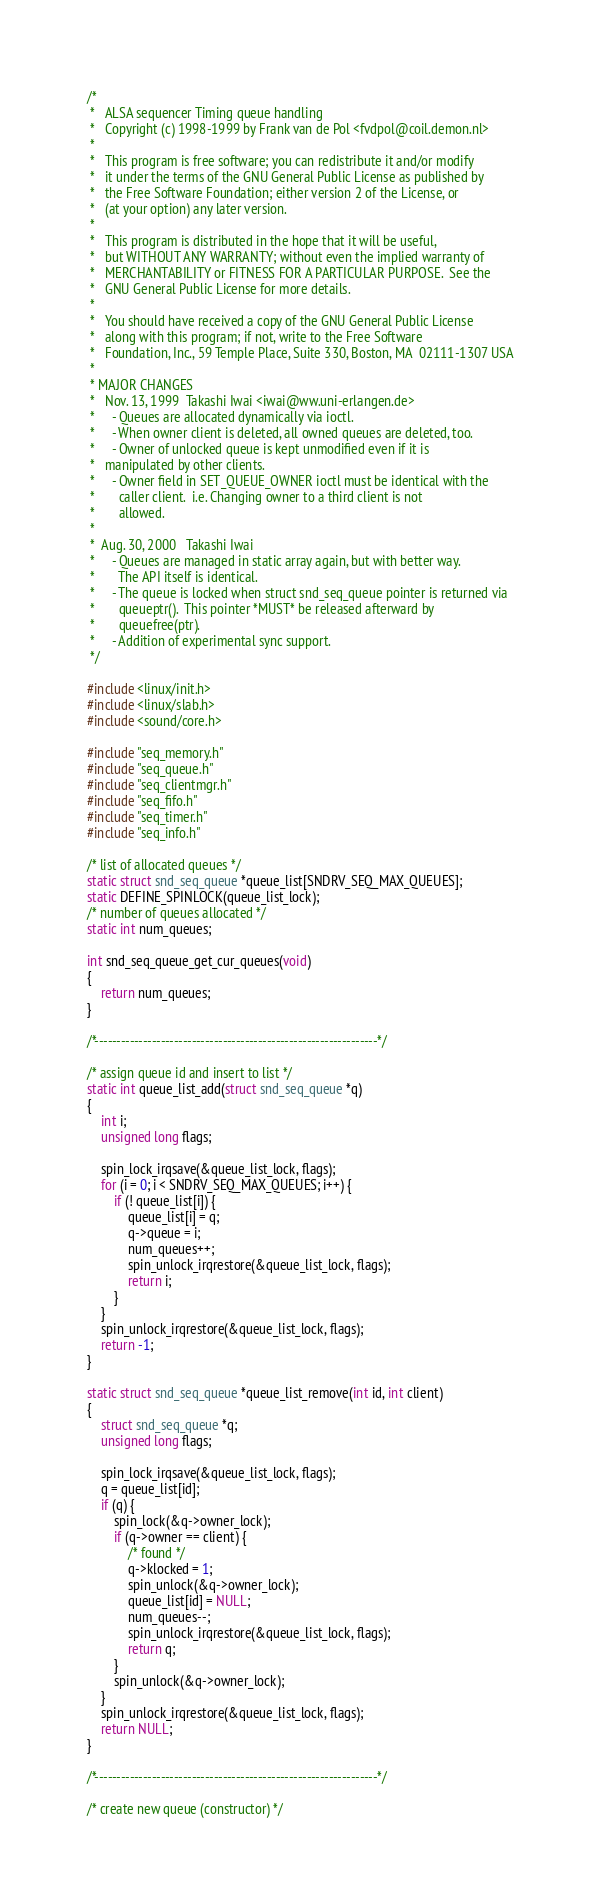Convert code to text. <code><loc_0><loc_0><loc_500><loc_500><_C_>/*
 *   ALSA sequencer Timing queue handling
 *   Copyright (c) 1998-1999 by Frank van de Pol <fvdpol@coil.demon.nl>
 *
 *   This program is free software; you can redistribute it and/or modify
 *   it under the terms of the GNU General Public License as published by
 *   the Free Software Foundation; either version 2 of the License, or
 *   (at your option) any later version.
 *
 *   This program is distributed in the hope that it will be useful,
 *   but WITHOUT ANY WARRANTY; without even the implied warranty of
 *   MERCHANTABILITY or FITNESS FOR A PARTICULAR PURPOSE.  See the
 *   GNU General Public License for more details.
 *
 *   You should have received a copy of the GNU General Public License
 *   along with this program; if not, write to the Free Software
 *   Foundation, Inc., 59 Temple Place, Suite 330, Boston, MA  02111-1307 USA
 *
 * MAJOR CHANGES
 *   Nov. 13, 1999	Takashi Iwai <iwai@ww.uni-erlangen.de>
 *     - Queues are allocated dynamically via ioctl.
 *     - When owner client is deleted, all owned queues are deleted, too.
 *     - Owner of unlocked queue is kept unmodified even if it is
 *	 manipulated by other clients.
 *     - Owner field in SET_QUEUE_OWNER ioctl must be identical with the
 *       caller client.  i.e. Changing owner to a third client is not
 *       allowed.
 *
 *  Aug. 30, 2000	Takashi Iwai
 *     - Queues are managed in static array again, but with better way.
 *       The API itself is identical.
 *     - The queue is locked when struct snd_seq_queue pointer is returned via
 *       queueptr().  This pointer *MUST* be released afterward by
 *       queuefree(ptr).
 *     - Addition of experimental sync support.
 */

#include <linux/init.h>
#include <linux/slab.h>
#include <sound/core.h>

#include "seq_memory.h"
#include "seq_queue.h"
#include "seq_clientmgr.h"
#include "seq_fifo.h"
#include "seq_timer.h"
#include "seq_info.h"

/* list of allocated queues */
static struct snd_seq_queue *queue_list[SNDRV_SEQ_MAX_QUEUES];
static DEFINE_SPINLOCK(queue_list_lock);
/* number of queues allocated */
static int num_queues;

int snd_seq_queue_get_cur_queues(void)
{
	return num_queues;
}

/*----------------------------------------------------------------*/

/* assign queue id and insert to list */
static int queue_list_add(struct snd_seq_queue *q)
{
	int i;
	unsigned long flags;

	spin_lock_irqsave(&queue_list_lock, flags);
	for (i = 0; i < SNDRV_SEQ_MAX_QUEUES; i++) {
		if (! queue_list[i]) {
			queue_list[i] = q;
			q->queue = i;
			num_queues++;
			spin_unlock_irqrestore(&queue_list_lock, flags);
			return i;
		}
	}
	spin_unlock_irqrestore(&queue_list_lock, flags);
	return -1;
}

static struct snd_seq_queue *queue_list_remove(int id, int client)
{
	struct snd_seq_queue *q;
	unsigned long flags;

	spin_lock_irqsave(&queue_list_lock, flags);
	q = queue_list[id];
	if (q) {
		spin_lock(&q->owner_lock);
		if (q->owner == client) {
			/* found */
			q->klocked = 1;
			spin_unlock(&q->owner_lock);
			queue_list[id] = NULL;
			num_queues--;
			spin_unlock_irqrestore(&queue_list_lock, flags);
			return q;
		}
		spin_unlock(&q->owner_lock);
	}
	spin_unlock_irqrestore(&queue_list_lock, flags);
	return NULL;
}

/*----------------------------------------------------------------*/

/* create new queue (constructor) */</code> 